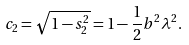Convert formula to latex. <formula><loc_0><loc_0><loc_500><loc_500>c _ { 2 } = \sqrt { 1 - s _ { 2 } ^ { 2 } } = 1 - \frac { 1 } { 2 } b ^ { 2 } \lambda ^ { 2 } .</formula> 